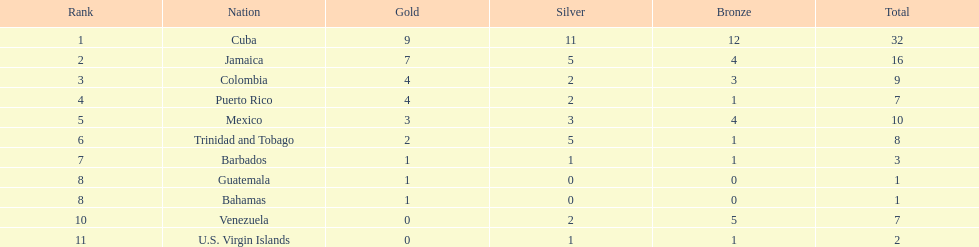Only team to have more than 30 medals Cuba. 